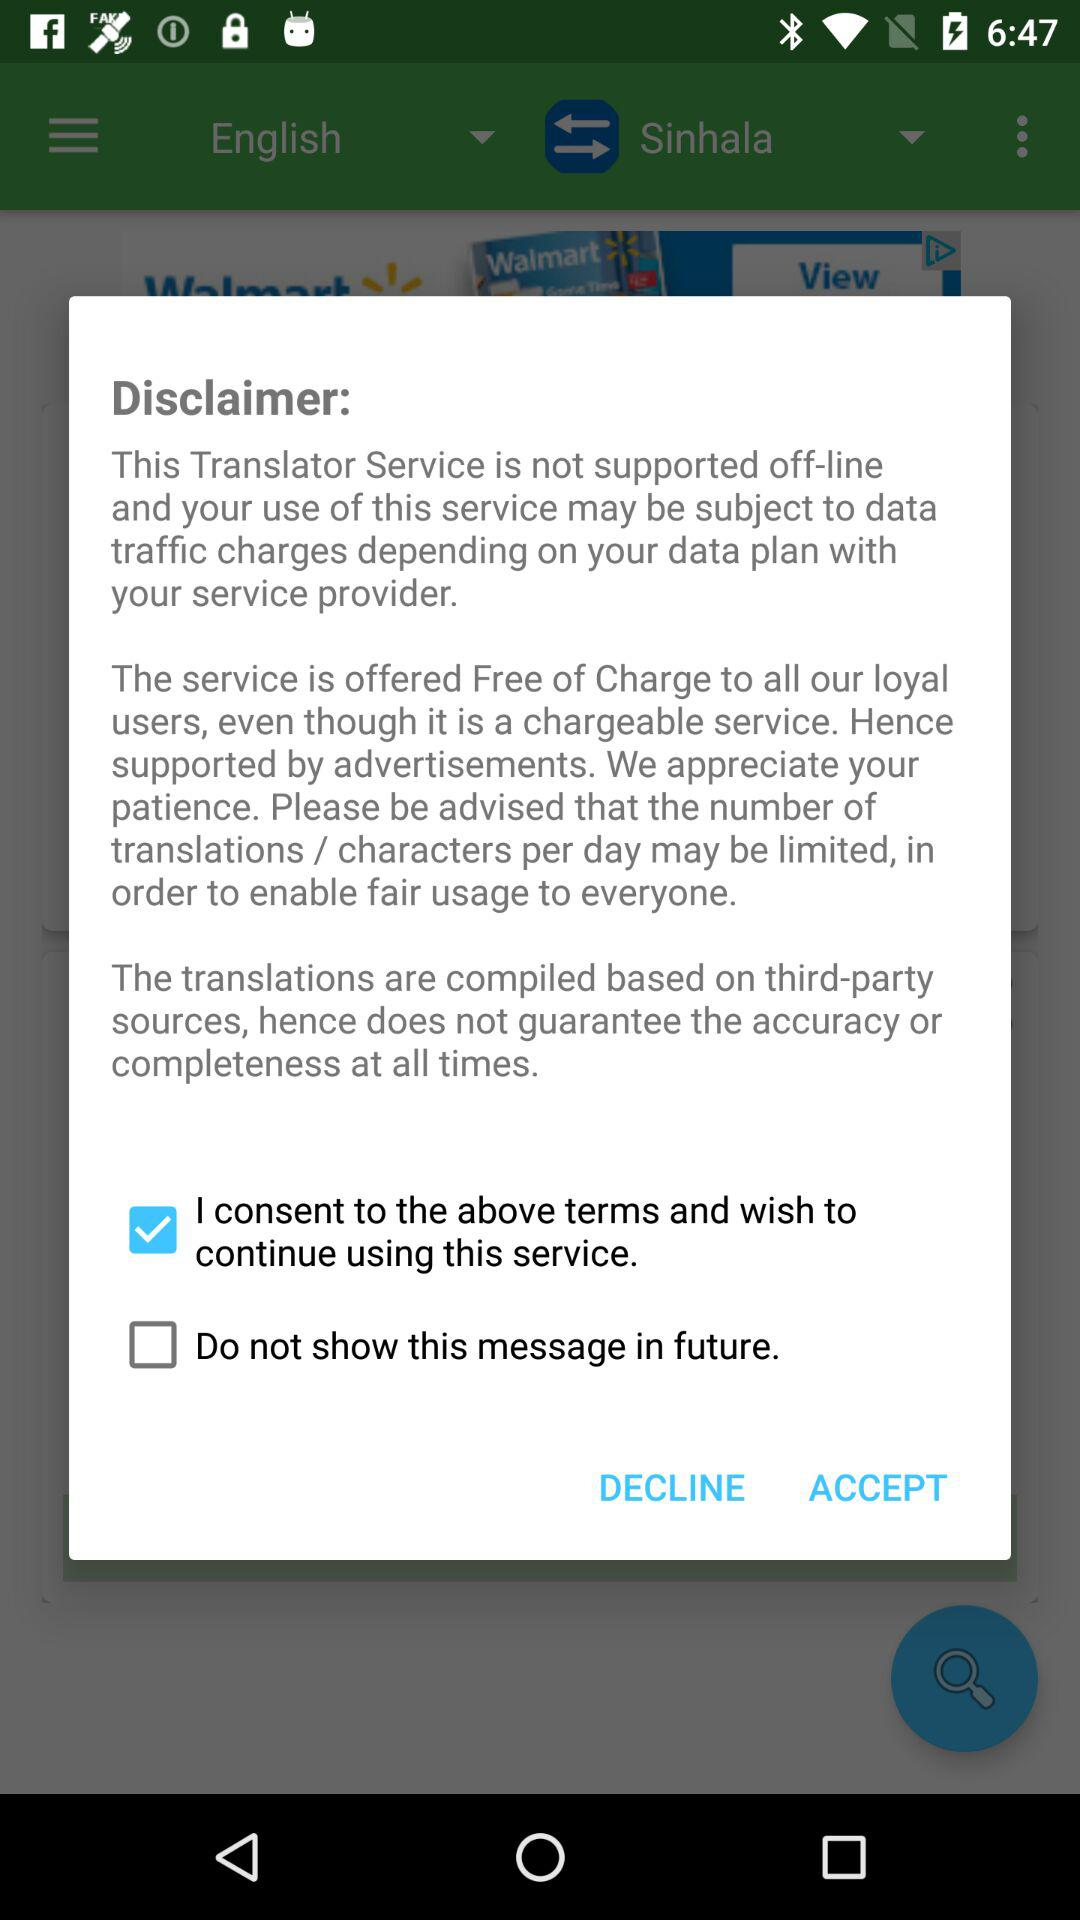Which option is checked? The checked option is "I consent to the above terms and wish to continue using this service.". 